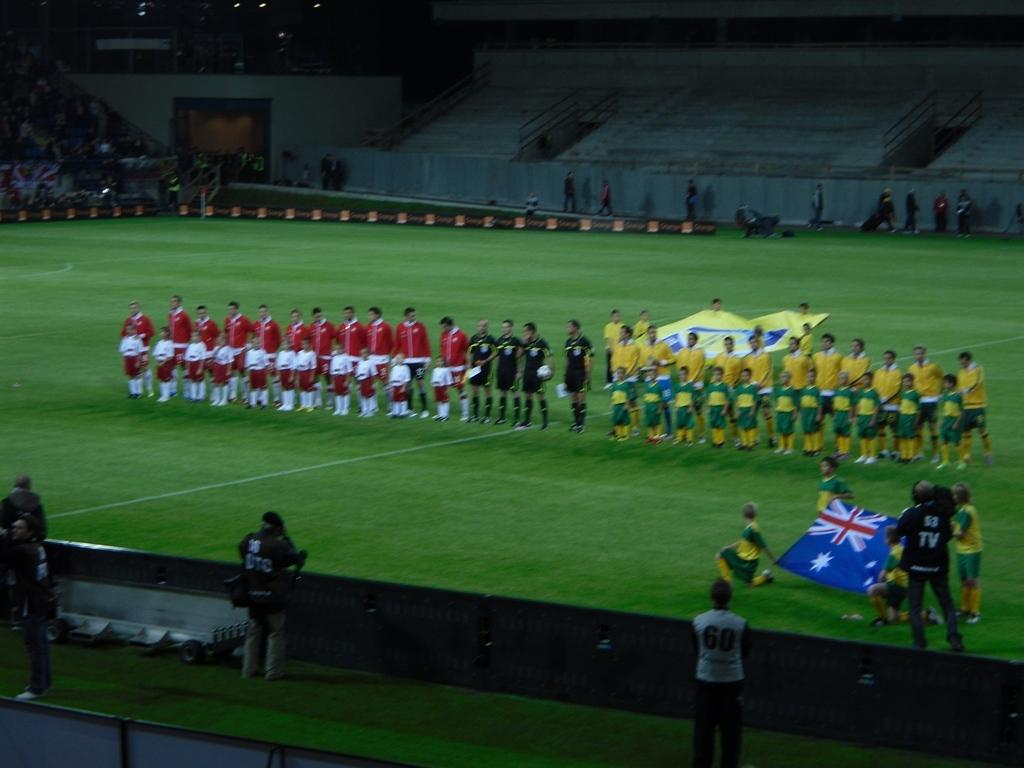<image>
Create a compact narrative representing the image presented. soccer teams stand together in middle of field while someone with a jacket with tv on it films 